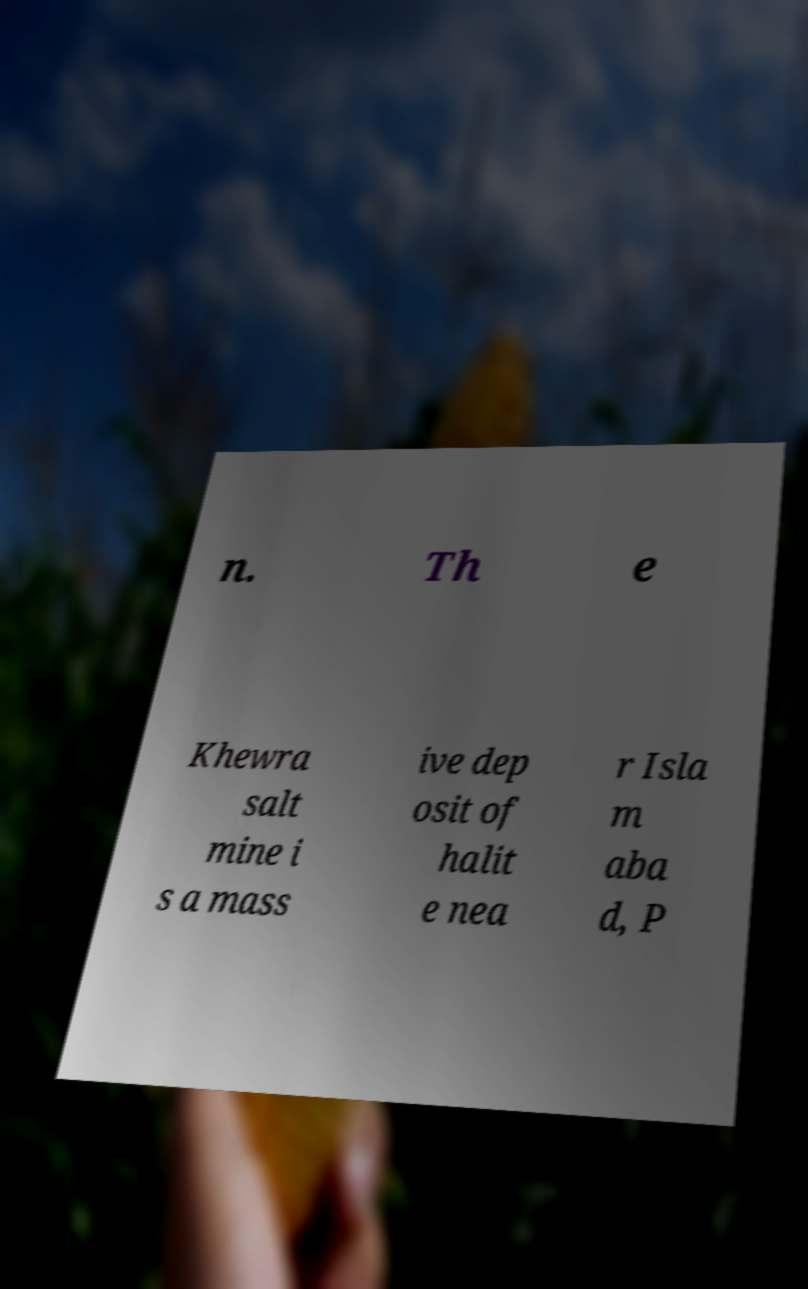I need the written content from this picture converted into text. Can you do that? n. Th e Khewra salt mine i s a mass ive dep osit of halit e nea r Isla m aba d, P 